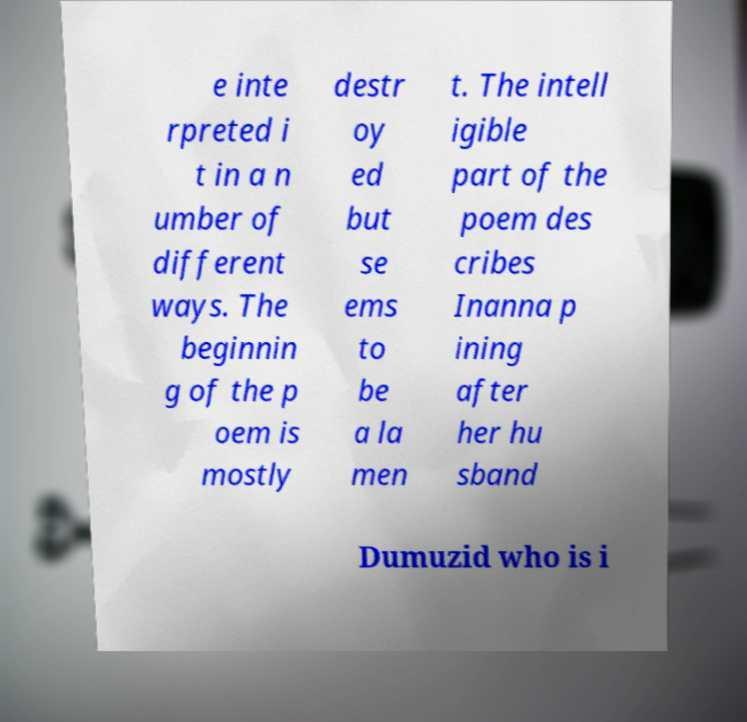Can you read and provide the text displayed in the image?This photo seems to have some interesting text. Can you extract and type it out for me? e inte rpreted i t in a n umber of different ways. The beginnin g of the p oem is mostly destr oy ed but se ems to be a la men t. The intell igible part of the poem des cribes Inanna p ining after her hu sband Dumuzid who is i 